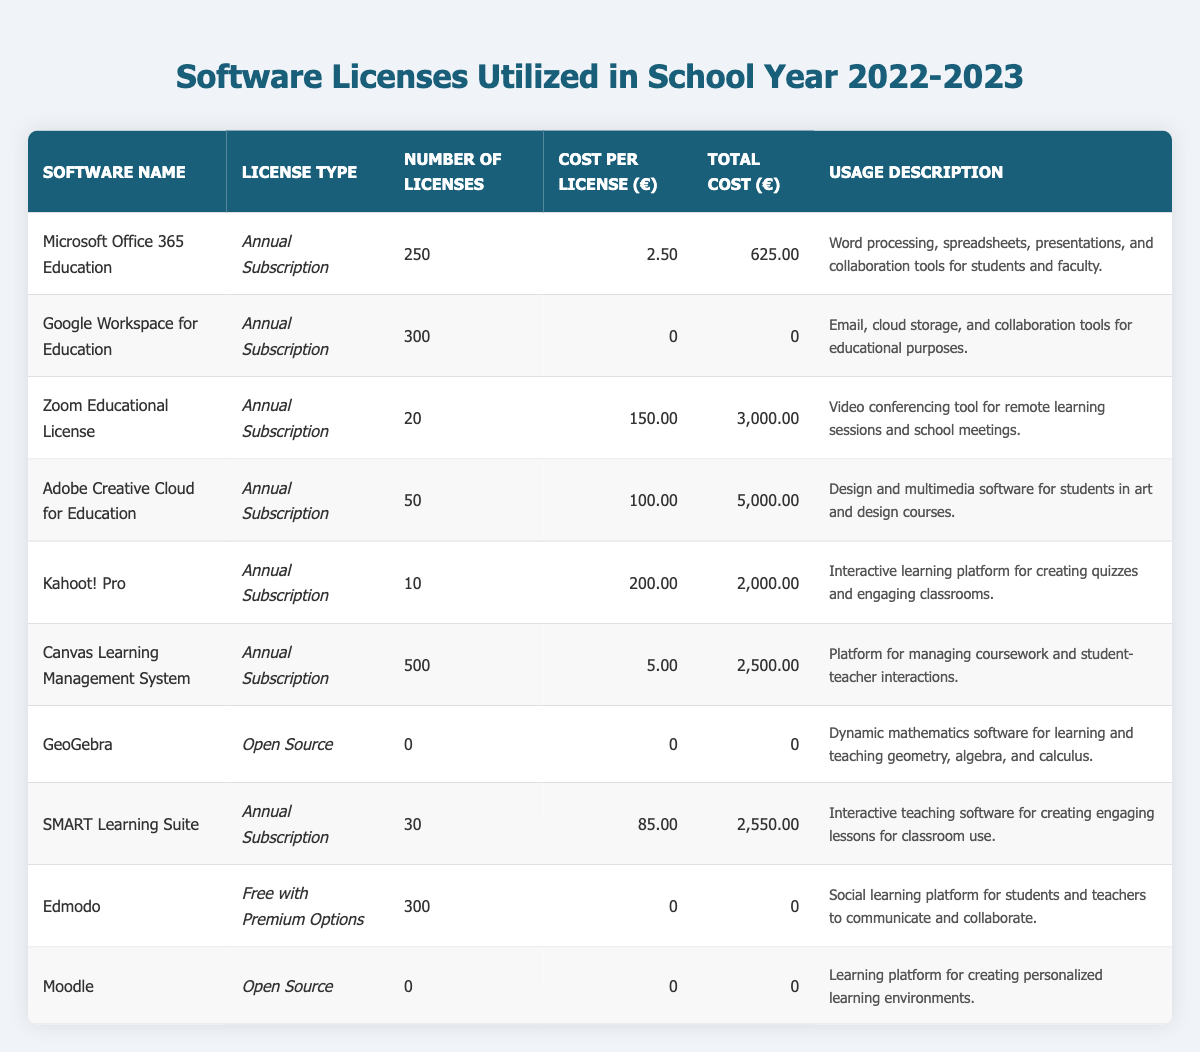What is the total cost of licenses for Microsoft Office 365 Education? The total cost for Microsoft Office 365 Education is provided in the table as €625.00.
Answer: €625.00 How many licenses are available for Google Workspace for Education? The number of licenses for Google Workspace for Education is listed in the table as 300.
Answer: 300 What is the cost per license for Adobe Creative Cloud for Education? The cost per license for Adobe Creative Cloud for Education is stated in the table as €100.00.
Answer: €100.00 Which software has the highest total cost? To find the software with the highest total cost, we can compare total costs listed in the table: Adobe Creative Cloud for Education is €5,000.00, which is higher than the others.
Answer: Adobe Creative Cloud for Education What is the total cost of all licenses combined? Adding all total costs: 625 + 0 + 3000 + 5000 + 2000 + 2500 + 0 + 2550 + 0 + 0 gives €17525.
Answer: €17,525.00 Is the license for GeoGebra paid or free? The license type for GeoGebra is mentioned as "Open Source," which typically implies it's free.
Answer: Yes How many different types of licenses are utilized in the table? By observing the license type column: Annual Subscription, Open Source, and Free with Premium Options are the types present, amounting to three different types.
Answer: 3 What is the total number of licenses for the Canvas Learning Management System? The table indicates that there are 500 licenses for Canvas Learning Management System listed.
Answer: 500 What is the average cost per license across all subscriptions? First, add the total cost of licensed software: 625 + 0 + 3000 + 5000 + 2000 + 2500 + 2550 = €17525. These costs are supported by 250 + 300 + 20 + 50 + 10 + 500 + 30 = 1160 licenses. The average cost per license is 17525 / 1160 = approximately €15.11.
Answer: €15.11 Which software has the least number of licenses? Comparing the number of licenses, GeoGebra has 0 licenses listed, indicating it does not require a paid license.
Answer: GeoGebra 